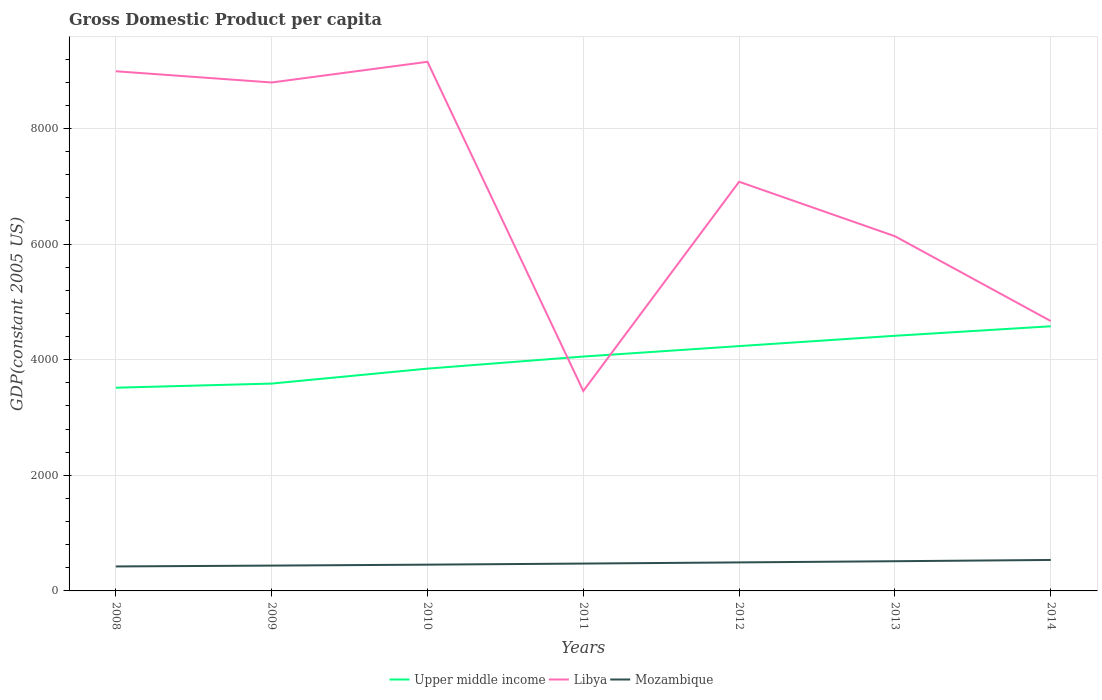How many different coloured lines are there?
Ensure brevity in your answer.  3. Does the line corresponding to Upper middle income intersect with the line corresponding to Mozambique?
Your answer should be compact. No. Across all years, what is the maximum GDP per capita in Mozambique?
Make the answer very short. 423.64. What is the total GDP per capita in Upper middle income in the graph?
Make the answer very short. -209.02. What is the difference between the highest and the second highest GDP per capita in Libya?
Provide a succinct answer. 5694.55. What is the difference between the highest and the lowest GDP per capita in Mozambique?
Keep it short and to the point. 3. How many years are there in the graph?
Make the answer very short. 7. What is the difference between two consecutive major ticks on the Y-axis?
Make the answer very short. 2000. Does the graph contain grids?
Provide a short and direct response. Yes. Where does the legend appear in the graph?
Keep it short and to the point. Bottom center. How are the legend labels stacked?
Provide a short and direct response. Horizontal. What is the title of the graph?
Keep it short and to the point. Gross Domestic Product per capita. Does "Gabon" appear as one of the legend labels in the graph?
Ensure brevity in your answer.  No. What is the label or title of the X-axis?
Provide a short and direct response. Years. What is the label or title of the Y-axis?
Offer a terse response. GDP(constant 2005 US). What is the GDP(constant 2005 US) of Upper middle income in 2008?
Ensure brevity in your answer.  3515.53. What is the GDP(constant 2005 US) of Libya in 2008?
Offer a very short reply. 8989.59. What is the GDP(constant 2005 US) in Mozambique in 2008?
Ensure brevity in your answer.  423.64. What is the GDP(constant 2005 US) in Upper middle income in 2009?
Your answer should be compact. 3586.78. What is the GDP(constant 2005 US) of Libya in 2009?
Give a very brief answer. 8795.52. What is the GDP(constant 2005 US) in Mozambique in 2009?
Your answer should be compact. 438.11. What is the GDP(constant 2005 US) in Upper middle income in 2010?
Ensure brevity in your answer.  3845.58. What is the GDP(constant 2005 US) in Libya in 2010?
Ensure brevity in your answer.  9153.11. What is the GDP(constant 2005 US) of Mozambique in 2010?
Make the answer very short. 454.46. What is the GDP(constant 2005 US) of Upper middle income in 2011?
Keep it short and to the point. 4054.59. What is the GDP(constant 2005 US) in Libya in 2011?
Give a very brief answer. 3458.56. What is the GDP(constant 2005 US) in Mozambique in 2011?
Your response must be concise. 473.27. What is the GDP(constant 2005 US) of Upper middle income in 2012?
Your response must be concise. 4235.11. What is the GDP(constant 2005 US) of Libya in 2012?
Provide a short and direct response. 7078.21. What is the GDP(constant 2005 US) of Mozambique in 2012?
Your answer should be very brief. 493.23. What is the GDP(constant 2005 US) of Upper middle income in 2013?
Offer a very short reply. 4413.71. What is the GDP(constant 2005 US) in Libya in 2013?
Provide a succinct answer. 6135.95. What is the GDP(constant 2005 US) of Mozambique in 2013?
Make the answer very short. 513.79. What is the GDP(constant 2005 US) of Upper middle income in 2014?
Offer a terse response. 4578.15. What is the GDP(constant 2005 US) in Libya in 2014?
Offer a terse response. 4668.54. What is the GDP(constant 2005 US) in Mozambique in 2014?
Provide a short and direct response. 535.73. Across all years, what is the maximum GDP(constant 2005 US) of Upper middle income?
Offer a very short reply. 4578.15. Across all years, what is the maximum GDP(constant 2005 US) in Libya?
Your response must be concise. 9153.11. Across all years, what is the maximum GDP(constant 2005 US) of Mozambique?
Ensure brevity in your answer.  535.73. Across all years, what is the minimum GDP(constant 2005 US) in Upper middle income?
Offer a terse response. 3515.53. Across all years, what is the minimum GDP(constant 2005 US) in Libya?
Keep it short and to the point. 3458.56. Across all years, what is the minimum GDP(constant 2005 US) in Mozambique?
Your answer should be compact. 423.64. What is the total GDP(constant 2005 US) in Upper middle income in the graph?
Make the answer very short. 2.82e+04. What is the total GDP(constant 2005 US) in Libya in the graph?
Offer a very short reply. 4.83e+04. What is the total GDP(constant 2005 US) in Mozambique in the graph?
Provide a short and direct response. 3332.23. What is the difference between the GDP(constant 2005 US) in Upper middle income in 2008 and that in 2009?
Offer a terse response. -71.25. What is the difference between the GDP(constant 2005 US) of Libya in 2008 and that in 2009?
Keep it short and to the point. 194.08. What is the difference between the GDP(constant 2005 US) of Mozambique in 2008 and that in 2009?
Ensure brevity in your answer.  -14.47. What is the difference between the GDP(constant 2005 US) in Upper middle income in 2008 and that in 2010?
Keep it short and to the point. -330.05. What is the difference between the GDP(constant 2005 US) of Libya in 2008 and that in 2010?
Make the answer very short. -163.52. What is the difference between the GDP(constant 2005 US) of Mozambique in 2008 and that in 2010?
Provide a succinct answer. -30.82. What is the difference between the GDP(constant 2005 US) in Upper middle income in 2008 and that in 2011?
Ensure brevity in your answer.  -539.06. What is the difference between the GDP(constant 2005 US) of Libya in 2008 and that in 2011?
Provide a succinct answer. 5531.03. What is the difference between the GDP(constant 2005 US) in Mozambique in 2008 and that in 2011?
Provide a short and direct response. -49.63. What is the difference between the GDP(constant 2005 US) in Upper middle income in 2008 and that in 2012?
Keep it short and to the point. -719.59. What is the difference between the GDP(constant 2005 US) in Libya in 2008 and that in 2012?
Make the answer very short. 1911.38. What is the difference between the GDP(constant 2005 US) of Mozambique in 2008 and that in 2012?
Your response must be concise. -69.58. What is the difference between the GDP(constant 2005 US) in Upper middle income in 2008 and that in 2013?
Keep it short and to the point. -898.18. What is the difference between the GDP(constant 2005 US) in Libya in 2008 and that in 2013?
Your response must be concise. 2853.64. What is the difference between the GDP(constant 2005 US) in Mozambique in 2008 and that in 2013?
Offer a terse response. -90.15. What is the difference between the GDP(constant 2005 US) in Upper middle income in 2008 and that in 2014?
Your answer should be compact. -1062.62. What is the difference between the GDP(constant 2005 US) in Libya in 2008 and that in 2014?
Make the answer very short. 4321.05. What is the difference between the GDP(constant 2005 US) of Mozambique in 2008 and that in 2014?
Provide a short and direct response. -112.09. What is the difference between the GDP(constant 2005 US) in Upper middle income in 2009 and that in 2010?
Ensure brevity in your answer.  -258.79. What is the difference between the GDP(constant 2005 US) of Libya in 2009 and that in 2010?
Offer a very short reply. -357.59. What is the difference between the GDP(constant 2005 US) of Mozambique in 2009 and that in 2010?
Make the answer very short. -16.35. What is the difference between the GDP(constant 2005 US) of Upper middle income in 2009 and that in 2011?
Offer a very short reply. -467.81. What is the difference between the GDP(constant 2005 US) of Libya in 2009 and that in 2011?
Offer a terse response. 5336.95. What is the difference between the GDP(constant 2005 US) of Mozambique in 2009 and that in 2011?
Make the answer very short. -35.17. What is the difference between the GDP(constant 2005 US) of Upper middle income in 2009 and that in 2012?
Your response must be concise. -648.33. What is the difference between the GDP(constant 2005 US) in Libya in 2009 and that in 2012?
Provide a short and direct response. 1717.31. What is the difference between the GDP(constant 2005 US) in Mozambique in 2009 and that in 2012?
Ensure brevity in your answer.  -55.12. What is the difference between the GDP(constant 2005 US) in Upper middle income in 2009 and that in 2013?
Make the answer very short. -826.92. What is the difference between the GDP(constant 2005 US) in Libya in 2009 and that in 2013?
Offer a terse response. 2659.57. What is the difference between the GDP(constant 2005 US) of Mozambique in 2009 and that in 2013?
Your response must be concise. -75.68. What is the difference between the GDP(constant 2005 US) in Upper middle income in 2009 and that in 2014?
Ensure brevity in your answer.  -991.37. What is the difference between the GDP(constant 2005 US) of Libya in 2009 and that in 2014?
Keep it short and to the point. 4126.98. What is the difference between the GDP(constant 2005 US) of Mozambique in 2009 and that in 2014?
Your response must be concise. -97.62. What is the difference between the GDP(constant 2005 US) of Upper middle income in 2010 and that in 2011?
Offer a very short reply. -209.02. What is the difference between the GDP(constant 2005 US) of Libya in 2010 and that in 2011?
Offer a terse response. 5694.55. What is the difference between the GDP(constant 2005 US) of Mozambique in 2010 and that in 2011?
Your response must be concise. -18.81. What is the difference between the GDP(constant 2005 US) of Upper middle income in 2010 and that in 2012?
Your answer should be compact. -389.54. What is the difference between the GDP(constant 2005 US) of Libya in 2010 and that in 2012?
Offer a very short reply. 2074.9. What is the difference between the GDP(constant 2005 US) in Mozambique in 2010 and that in 2012?
Offer a terse response. -38.76. What is the difference between the GDP(constant 2005 US) of Upper middle income in 2010 and that in 2013?
Provide a short and direct response. -568.13. What is the difference between the GDP(constant 2005 US) in Libya in 2010 and that in 2013?
Your answer should be compact. 3017.16. What is the difference between the GDP(constant 2005 US) in Mozambique in 2010 and that in 2013?
Offer a terse response. -59.33. What is the difference between the GDP(constant 2005 US) of Upper middle income in 2010 and that in 2014?
Keep it short and to the point. -732.57. What is the difference between the GDP(constant 2005 US) in Libya in 2010 and that in 2014?
Offer a terse response. 4484.57. What is the difference between the GDP(constant 2005 US) in Mozambique in 2010 and that in 2014?
Offer a very short reply. -81.26. What is the difference between the GDP(constant 2005 US) of Upper middle income in 2011 and that in 2012?
Give a very brief answer. -180.52. What is the difference between the GDP(constant 2005 US) of Libya in 2011 and that in 2012?
Your answer should be compact. -3619.65. What is the difference between the GDP(constant 2005 US) of Mozambique in 2011 and that in 2012?
Your response must be concise. -19.95. What is the difference between the GDP(constant 2005 US) of Upper middle income in 2011 and that in 2013?
Provide a short and direct response. -359.11. What is the difference between the GDP(constant 2005 US) of Libya in 2011 and that in 2013?
Offer a terse response. -2677.39. What is the difference between the GDP(constant 2005 US) in Mozambique in 2011 and that in 2013?
Your answer should be very brief. -40.52. What is the difference between the GDP(constant 2005 US) of Upper middle income in 2011 and that in 2014?
Offer a very short reply. -523.56. What is the difference between the GDP(constant 2005 US) in Libya in 2011 and that in 2014?
Your response must be concise. -1209.98. What is the difference between the GDP(constant 2005 US) in Mozambique in 2011 and that in 2014?
Provide a short and direct response. -62.45. What is the difference between the GDP(constant 2005 US) in Upper middle income in 2012 and that in 2013?
Your answer should be very brief. -178.59. What is the difference between the GDP(constant 2005 US) of Libya in 2012 and that in 2013?
Keep it short and to the point. 942.26. What is the difference between the GDP(constant 2005 US) of Mozambique in 2012 and that in 2013?
Make the answer very short. -20.56. What is the difference between the GDP(constant 2005 US) of Upper middle income in 2012 and that in 2014?
Your answer should be very brief. -343.03. What is the difference between the GDP(constant 2005 US) of Libya in 2012 and that in 2014?
Your answer should be very brief. 2409.67. What is the difference between the GDP(constant 2005 US) of Mozambique in 2012 and that in 2014?
Ensure brevity in your answer.  -42.5. What is the difference between the GDP(constant 2005 US) of Upper middle income in 2013 and that in 2014?
Offer a terse response. -164.44. What is the difference between the GDP(constant 2005 US) in Libya in 2013 and that in 2014?
Your response must be concise. 1467.41. What is the difference between the GDP(constant 2005 US) in Mozambique in 2013 and that in 2014?
Provide a succinct answer. -21.94. What is the difference between the GDP(constant 2005 US) in Upper middle income in 2008 and the GDP(constant 2005 US) in Libya in 2009?
Provide a short and direct response. -5279.99. What is the difference between the GDP(constant 2005 US) of Upper middle income in 2008 and the GDP(constant 2005 US) of Mozambique in 2009?
Provide a short and direct response. 3077.42. What is the difference between the GDP(constant 2005 US) in Libya in 2008 and the GDP(constant 2005 US) in Mozambique in 2009?
Give a very brief answer. 8551.48. What is the difference between the GDP(constant 2005 US) of Upper middle income in 2008 and the GDP(constant 2005 US) of Libya in 2010?
Make the answer very short. -5637.58. What is the difference between the GDP(constant 2005 US) of Upper middle income in 2008 and the GDP(constant 2005 US) of Mozambique in 2010?
Make the answer very short. 3061.07. What is the difference between the GDP(constant 2005 US) of Libya in 2008 and the GDP(constant 2005 US) of Mozambique in 2010?
Provide a short and direct response. 8535.13. What is the difference between the GDP(constant 2005 US) in Upper middle income in 2008 and the GDP(constant 2005 US) in Libya in 2011?
Keep it short and to the point. 56.97. What is the difference between the GDP(constant 2005 US) in Upper middle income in 2008 and the GDP(constant 2005 US) in Mozambique in 2011?
Your response must be concise. 3042.25. What is the difference between the GDP(constant 2005 US) of Libya in 2008 and the GDP(constant 2005 US) of Mozambique in 2011?
Ensure brevity in your answer.  8516.32. What is the difference between the GDP(constant 2005 US) in Upper middle income in 2008 and the GDP(constant 2005 US) in Libya in 2012?
Make the answer very short. -3562.68. What is the difference between the GDP(constant 2005 US) in Upper middle income in 2008 and the GDP(constant 2005 US) in Mozambique in 2012?
Keep it short and to the point. 3022.3. What is the difference between the GDP(constant 2005 US) in Libya in 2008 and the GDP(constant 2005 US) in Mozambique in 2012?
Ensure brevity in your answer.  8496.37. What is the difference between the GDP(constant 2005 US) in Upper middle income in 2008 and the GDP(constant 2005 US) in Libya in 2013?
Give a very brief answer. -2620.42. What is the difference between the GDP(constant 2005 US) of Upper middle income in 2008 and the GDP(constant 2005 US) of Mozambique in 2013?
Your answer should be compact. 3001.74. What is the difference between the GDP(constant 2005 US) in Libya in 2008 and the GDP(constant 2005 US) in Mozambique in 2013?
Ensure brevity in your answer.  8475.8. What is the difference between the GDP(constant 2005 US) of Upper middle income in 2008 and the GDP(constant 2005 US) of Libya in 2014?
Ensure brevity in your answer.  -1153.01. What is the difference between the GDP(constant 2005 US) of Upper middle income in 2008 and the GDP(constant 2005 US) of Mozambique in 2014?
Keep it short and to the point. 2979.8. What is the difference between the GDP(constant 2005 US) in Libya in 2008 and the GDP(constant 2005 US) in Mozambique in 2014?
Offer a terse response. 8453.86. What is the difference between the GDP(constant 2005 US) in Upper middle income in 2009 and the GDP(constant 2005 US) in Libya in 2010?
Your response must be concise. -5566.32. What is the difference between the GDP(constant 2005 US) in Upper middle income in 2009 and the GDP(constant 2005 US) in Mozambique in 2010?
Your answer should be compact. 3132.32. What is the difference between the GDP(constant 2005 US) of Libya in 2009 and the GDP(constant 2005 US) of Mozambique in 2010?
Give a very brief answer. 8341.05. What is the difference between the GDP(constant 2005 US) of Upper middle income in 2009 and the GDP(constant 2005 US) of Libya in 2011?
Offer a very short reply. 128.22. What is the difference between the GDP(constant 2005 US) in Upper middle income in 2009 and the GDP(constant 2005 US) in Mozambique in 2011?
Make the answer very short. 3113.51. What is the difference between the GDP(constant 2005 US) of Libya in 2009 and the GDP(constant 2005 US) of Mozambique in 2011?
Make the answer very short. 8322.24. What is the difference between the GDP(constant 2005 US) in Upper middle income in 2009 and the GDP(constant 2005 US) in Libya in 2012?
Give a very brief answer. -3491.43. What is the difference between the GDP(constant 2005 US) in Upper middle income in 2009 and the GDP(constant 2005 US) in Mozambique in 2012?
Ensure brevity in your answer.  3093.56. What is the difference between the GDP(constant 2005 US) in Libya in 2009 and the GDP(constant 2005 US) in Mozambique in 2012?
Offer a very short reply. 8302.29. What is the difference between the GDP(constant 2005 US) in Upper middle income in 2009 and the GDP(constant 2005 US) in Libya in 2013?
Your answer should be compact. -2549.17. What is the difference between the GDP(constant 2005 US) in Upper middle income in 2009 and the GDP(constant 2005 US) in Mozambique in 2013?
Your response must be concise. 3072.99. What is the difference between the GDP(constant 2005 US) of Libya in 2009 and the GDP(constant 2005 US) of Mozambique in 2013?
Provide a succinct answer. 8281.73. What is the difference between the GDP(constant 2005 US) in Upper middle income in 2009 and the GDP(constant 2005 US) in Libya in 2014?
Your response must be concise. -1081.76. What is the difference between the GDP(constant 2005 US) of Upper middle income in 2009 and the GDP(constant 2005 US) of Mozambique in 2014?
Ensure brevity in your answer.  3051.06. What is the difference between the GDP(constant 2005 US) of Libya in 2009 and the GDP(constant 2005 US) of Mozambique in 2014?
Keep it short and to the point. 8259.79. What is the difference between the GDP(constant 2005 US) in Upper middle income in 2010 and the GDP(constant 2005 US) in Libya in 2011?
Make the answer very short. 387.01. What is the difference between the GDP(constant 2005 US) of Upper middle income in 2010 and the GDP(constant 2005 US) of Mozambique in 2011?
Provide a succinct answer. 3372.3. What is the difference between the GDP(constant 2005 US) of Libya in 2010 and the GDP(constant 2005 US) of Mozambique in 2011?
Provide a succinct answer. 8679.83. What is the difference between the GDP(constant 2005 US) in Upper middle income in 2010 and the GDP(constant 2005 US) in Libya in 2012?
Offer a terse response. -3232.63. What is the difference between the GDP(constant 2005 US) in Upper middle income in 2010 and the GDP(constant 2005 US) in Mozambique in 2012?
Offer a very short reply. 3352.35. What is the difference between the GDP(constant 2005 US) in Libya in 2010 and the GDP(constant 2005 US) in Mozambique in 2012?
Keep it short and to the point. 8659.88. What is the difference between the GDP(constant 2005 US) of Upper middle income in 2010 and the GDP(constant 2005 US) of Libya in 2013?
Your answer should be compact. -2290.37. What is the difference between the GDP(constant 2005 US) of Upper middle income in 2010 and the GDP(constant 2005 US) of Mozambique in 2013?
Your answer should be compact. 3331.79. What is the difference between the GDP(constant 2005 US) in Libya in 2010 and the GDP(constant 2005 US) in Mozambique in 2013?
Your answer should be compact. 8639.32. What is the difference between the GDP(constant 2005 US) in Upper middle income in 2010 and the GDP(constant 2005 US) in Libya in 2014?
Offer a terse response. -822.96. What is the difference between the GDP(constant 2005 US) in Upper middle income in 2010 and the GDP(constant 2005 US) in Mozambique in 2014?
Provide a short and direct response. 3309.85. What is the difference between the GDP(constant 2005 US) in Libya in 2010 and the GDP(constant 2005 US) in Mozambique in 2014?
Make the answer very short. 8617.38. What is the difference between the GDP(constant 2005 US) in Upper middle income in 2011 and the GDP(constant 2005 US) in Libya in 2012?
Your answer should be very brief. -3023.62. What is the difference between the GDP(constant 2005 US) in Upper middle income in 2011 and the GDP(constant 2005 US) in Mozambique in 2012?
Your answer should be compact. 3561.37. What is the difference between the GDP(constant 2005 US) in Libya in 2011 and the GDP(constant 2005 US) in Mozambique in 2012?
Give a very brief answer. 2965.34. What is the difference between the GDP(constant 2005 US) of Upper middle income in 2011 and the GDP(constant 2005 US) of Libya in 2013?
Provide a short and direct response. -2081.36. What is the difference between the GDP(constant 2005 US) in Upper middle income in 2011 and the GDP(constant 2005 US) in Mozambique in 2013?
Your answer should be compact. 3540.8. What is the difference between the GDP(constant 2005 US) in Libya in 2011 and the GDP(constant 2005 US) in Mozambique in 2013?
Ensure brevity in your answer.  2944.77. What is the difference between the GDP(constant 2005 US) of Upper middle income in 2011 and the GDP(constant 2005 US) of Libya in 2014?
Ensure brevity in your answer.  -613.95. What is the difference between the GDP(constant 2005 US) of Upper middle income in 2011 and the GDP(constant 2005 US) of Mozambique in 2014?
Ensure brevity in your answer.  3518.87. What is the difference between the GDP(constant 2005 US) in Libya in 2011 and the GDP(constant 2005 US) in Mozambique in 2014?
Your response must be concise. 2922.83. What is the difference between the GDP(constant 2005 US) of Upper middle income in 2012 and the GDP(constant 2005 US) of Libya in 2013?
Your answer should be very brief. -1900.83. What is the difference between the GDP(constant 2005 US) of Upper middle income in 2012 and the GDP(constant 2005 US) of Mozambique in 2013?
Ensure brevity in your answer.  3721.32. What is the difference between the GDP(constant 2005 US) of Libya in 2012 and the GDP(constant 2005 US) of Mozambique in 2013?
Your response must be concise. 6564.42. What is the difference between the GDP(constant 2005 US) of Upper middle income in 2012 and the GDP(constant 2005 US) of Libya in 2014?
Keep it short and to the point. -433.42. What is the difference between the GDP(constant 2005 US) in Upper middle income in 2012 and the GDP(constant 2005 US) in Mozambique in 2014?
Ensure brevity in your answer.  3699.39. What is the difference between the GDP(constant 2005 US) in Libya in 2012 and the GDP(constant 2005 US) in Mozambique in 2014?
Offer a terse response. 6542.48. What is the difference between the GDP(constant 2005 US) of Upper middle income in 2013 and the GDP(constant 2005 US) of Libya in 2014?
Offer a very short reply. -254.83. What is the difference between the GDP(constant 2005 US) in Upper middle income in 2013 and the GDP(constant 2005 US) in Mozambique in 2014?
Offer a terse response. 3877.98. What is the difference between the GDP(constant 2005 US) in Libya in 2013 and the GDP(constant 2005 US) in Mozambique in 2014?
Your answer should be very brief. 5600.22. What is the average GDP(constant 2005 US) of Upper middle income per year?
Provide a short and direct response. 4032.78. What is the average GDP(constant 2005 US) in Libya per year?
Offer a terse response. 6897.07. What is the average GDP(constant 2005 US) in Mozambique per year?
Your answer should be compact. 476.03. In the year 2008, what is the difference between the GDP(constant 2005 US) of Upper middle income and GDP(constant 2005 US) of Libya?
Provide a short and direct response. -5474.06. In the year 2008, what is the difference between the GDP(constant 2005 US) of Upper middle income and GDP(constant 2005 US) of Mozambique?
Provide a succinct answer. 3091.89. In the year 2008, what is the difference between the GDP(constant 2005 US) in Libya and GDP(constant 2005 US) in Mozambique?
Ensure brevity in your answer.  8565.95. In the year 2009, what is the difference between the GDP(constant 2005 US) in Upper middle income and GDP(constant 2005 US) in Libya?
Offer a terse response. -5208.73. In the year 2009, what is the difference between the GDP(constant 2005 US) of Upper middle income and GDP(constant 2005 US) of Mozambique?
Keep it short and to the point. 3148.67. In the year 2009, what is the difference between the GDP(constant 2005 US) in Libya and GDP(constant 2005 US) in Mozambique?
Ensure brevity in your answer.  8357.41. In the year 2010, what is the difference between the GDP(constant 2005 US) of Upper middle income and GDP(constant 2005 US) of Libya?
Offer a terse response. -5307.53. In the year 2010, what is the difference between the GDP(constant 2005 US) in Upper middle income and GDP(constant 2005 US) in Mozambique?
Your response must be concise. 3391.11. In the year 2010, what is the difference between the GDP(constant 2005 US) in Libya and GDP(constant 2005 US) in Mozambique?
Give a very brief answer. 8698.65. In the year 2011, what is the difference between the GDP(constant 2005 US) in Upper middle income and GDP(constant 2005 US) in Libya?
Offer a very short reply. 596.03. In the year 2011, what is the difference between the GDP(constant 2005 US) of Upper middle income and GDP(constant 2005 US) of Mozambique?
Your answer should be very brief. 3581.32. In the year 2011, what is the difference between the GDP(constant 2005 US) of Libya and GDP(constant 2005 US) of Mozambique?
Your answer should be very brief. 2985.29. In the year 2012, what is the difference between the GDP(constant 2005 US) in Upper middle income and GDP(constant 2005 US) in Libya?
Provide a succinct answer. -2843.09. In the year 2012, what is the difference between the GDP(constant 2005 US) of Upper middle income and GDP(constant 2005 US) of Mozambique?
Offer a very short reply. 3741.89. In the year 2012, what is the difference between the GDP(constant 2005 US) in Libya and GDP(constant 2005 US) in Mozambique?
Make the answer very short. 6584.98. In the year 2013, what is the difference between the GDP(constant 2005 US) of Upper middle income and GDP(constant 2005 US) of Libya?
Provide a succinct answer. -1722.24. In the year 2013, what is the difference between the GDP(constant 2005 US) of Upper middle income and GDP(constant 2005 US) of Mozambique?
Your response must be concise. 3899.92. In the year 2013, what is the difference between the GDP(constant 2005 US) in Libya and GDP(constant 2005 US) in Mozambique?
Provide a short and direct response. 5622.16. In the year 2014, what is the difference between the GDP(constant 2005 US) of Upper middle income and GDP(constant 2005 US) of Libya?
Provide a succinct answer. -90.39. In the year 2014, what is the difference between the GDP(constant 2005 US) of Upper middle income and GDP(constant 2005 US) of Mozambique?
Ensure brevity in your answer.  4042.42. In the year 2014, what is the difference between the GDP(constant 2005 US) of Libya and GDP(constant 2005 US) of Mozambique?
Provide a succinct answer. 4132.81. What is the ratio of the GDP(constant 2005 US) in Upper middle income in 2008 to that in 2009?
Give a very brief answer. 0.98. What is the ratio of the GDP(constant 2005 US) of Libya in 2008 to that in 2009?
Your response must be concise. 1.02. What is the ratio of the GDP(constant 2005 US) in Mozambique in 2008 to that in 2009?
Your response must be concise. 0.97. What is the ratio of the GDP(constant 2005 US) of Upper middle income in 2008 to that in 2010?
Provide a succinct answer. 0.91. What is the ratio of the GDP(constant 2005 US) of Libya in 2008 to that in 2010?
Offer a very short reply. 0.98. What is the ratio of the GDP(constant 2005 US) of Mozambique in 2008 to that in 2010?
Make the answer very short. 0.93. What is the ratio of the GDP(constant 2005 US) of Upper middle income in 2008 to that in 2011?
Ensure brevity in your answer.  0.87. What is the ratio of the GDP(constant 2005 US) of Libya in 2008 to that in 2011?
Ensure brevity in your answer.  2.6. What is the ratio of the GDP(constant 2005 US) in Mozambique in 2008 to that in 2011?
Your answer should be compact. 0.9. What is the ratio of the GDP(constant 2005 US) in Upper middle income in 2008 to that in 2012?
Your answer should be compact. 0.83. What is the ratio of the GDP(constant 2005 US) of Libya in 2008 to that in 2012?
Make the answer very short. 1.27. What is the ratio of the GDP(constant 2005 US) in Mozambique in 2008 to that in 2012?
Offer a terse response. 0.86. What is the ratio of the GDP(constant 2005 US) of Upper middle income in 2008 to that in 2013?
Give a very brief answer. 0.8. What is the ratio of the GDP(constant 2005 US) in Libya in 2008 to that in 2013?
Make the answer very short. 1.47. What is the ratio of the GDP(constant 2005 US) of Mozambique in 2008 to that in 2013?
Provide a short and direct response. 0.82. What is the ratio of the GDP(constant 2005 US) in Upper middle income in 2008 to that in 2014?
Provide a short and direct response. 0.77. What is the ratio of the GDP(constant 2005 US) of Libya in 2008 to that in 2014?
Keep it short and to the point. 1.93. What is the ratio of the GDP(constant 2005 US) of Mozambique in 2008 to that in 2014?
Your answer should be very brief. 0.79. What is the ratio of the GDP(constant 2005 US) in Upper middle income in 2009 to that in 2010?
Make the answer very short. 0.93. What is the ratio of the GDP(constant 2005 US) of Libya in 2009 to that in 2010?
Make the answer very short. 0.96. What is the ratio of the GDP(constant 2005 US) of Mozambique in 2009 to that in 2010?
Offer a very short reply. 0.96. What is the ratio of the GDP(constant 2005 US) in Upper middle income in 2009 to that in 2011?
Give a very brief answer. 0.88. What is the ratio of the GDP(constant 2005 US) of Libya in 2009 to that in 2011?
Make the answer very short. 2.54. What is the ratio of the GDP(constant 2005 US) in Mozambique in 2009 to that in 2011?
Make the answer very short. 0.93. What is the ratio of the GDP(constant 2005 US) of Upper middle income in 2009 to that in 2012?
Your answer should be very brief. 0.85. What is the ratio of the GDP(constant 2005 US) in Libya in 2009 to that in 2012?
Provide a succinct answer. 1.24. What is the ratio of the GDP(constant 2005 US) of Mozambique in 2009 to that in 2012?
Offer a terse response. 0.89. What is the ratio of the GDP(constant 2005 US) of Upper middle income in 2009 to that in 2013?
Ensure brevity in your answer.  0.81. What is the ratio of the GDP(constant 2005 US) of Libya in 2009 to that in 2013?
Make the answer very short. 1.43. What is the ratio of the GDP(constant 2005 US) of Mozambique in 2009 to that in 2013?
Your answer should be very brief. 0.85. What is the ratio of the GDP(constant 2005 US) of Upper middle income in 2009 to that in 2014?
Keep it short and to the point. 0.78. What is the ratio of the GDP(constant 2005 US) in Libya in 2009 to that in 2014?
Your answer should be compact. 1.88. What is the ratio of the GDP(constant 2005 US) of Mozambique in 2009 to that in 2014?
Ensure brevity in your answer.  0.82. What is the ratio of the GDP(constant 2005 US) in Upper middle income in 2010 to that in 2011?
Provide a short and direct response. 0.95. What is the ratio of the GDP(constant 2005 US) of Libya in 2010 to that in 2011?
Ensure brevity in your answer.  2.65. What is the ratio of the GDP(constant 2005 US) of Mozambique in 2010 to that in 2011?
Ensure brevity in your answer.  0.96. What is the ratio of the GDP(constant 2005 US) in Upper middle income in 2010 to that in 2012?
Your answer should be very brief. 0.91. What is the ratio of the GDP(constant 2005 US) in Libya in 2010 to that in 2012?
Offer a terse response. 1.29. What is the ratio of the GDP(constant 2005 US) of Mozambique in 2010 to that in 2012?
Your answer should be compact. 0.92. What is the ratio of the GDP(constant 2005 US) of Upper middle income in 2010 to that in 2013?
Your answer should be very brief. 0.87. What is the ratio of the GDP(constant 2005 US) in Libya in 2010 to that in 2013?
Your answer should be compact. 1.49. What is the ratio of the GDP(constant 2005 US) in Mozambique in 2010 to that in 2013?
Give a very brief answer. 0.88. What is the ratio of the GDP(constant 2005 US) in Upper middle income in 2010 to that in 2014?
Offer a terse response. 0.84. What is the ratio of the GDP(constant 2005 US) in Libya in 2010 to that in 2014?
Provide a succinct answer. 1.96. What is the ratio of the GDP(constant 2005 US) in Mozambique in 2010 to that in 2014?
Your response must be concise. 0.85. What is the ratio of the GDP(constant 2005 US) in Upper middle income in 2011 to that in 2012?
Keep it short and to the point. 0.96. What is the ratio of the GDP(constant 2005 US) of Libya in 2011 to that in 2012?
Keep it short and to the point. 0.49. What is the ratio of the GDP(constant 2005 US) in Mozambique in 2011 to that in 2012?
Offer a terse response. 0.96. What is the ratio of the GDP(constant 2005 US) in Upper middle income in 2011 to that in 2013?
Your response must be concise. 0.92. What is the ratio of the GDP(constant 2005 US) in Libya in 2011 to that in 2013?
Ensure brevity in your answer.  0.56. What is the ratio of the GDP(constant 2005 US) in Mozambique in 2011 to that in 2013?
Your response must be concise. 0.92. What is the ratio of the GDP(constant 2005 US) in Upper middle income in 2011 to that in 2014?
Give a very brief answer. 0.89. What is the ratio of the GDP(constant 2005 US) of Libya in 2011 to that in 2014?
Keep it short and to the point. 0.74. What is the ratio of the GDP(constant 2005 US) of Mozambique in 2011 to that in 2014?
Give a very brief answer. 0.88. What is the ratio of the GDP(constant 2005 US) in Upper middle income in 2012 to that in 2013?
Ensure brevity in your answer.  0.96. What is the ratio of the GDP(constant 2005 US) of Libya in 2012 to that in 2013?
Ensure brevity in your answer.  1.15. What is the ratio of the GDP(constant 2005 US) of Upper middle income in 2012 to that in 2014?
Keep it short and to the point. 0.93. What is the ratio of the GDP(constant 2005 US) in Libya in 2012 to that in 2014?
Offer a terse response. 1.52. What is the ratio of the GDP(constant 2005 US) in Mozambique in 2012 to that in 2014?
Provide a short and direct response. 0.92. What is the ratio of the GDP(constant 2005 US) in Upper middle income in 2013 to that in 2014?
Make the answer very short. 0.96. What is the ratio of the GDP(constant 2005 US) in Libya in 2013 to that in 2014?
Your answer should be very brief. 1.31. What is the ratio of the GDP(constant 2005 US) in Mozambique in 2013 to that in 2014?
Provide a succinct answer. 0.96. What is the difference between the highest and the second highest GDP(constant 2005 US) in Upper middle income?
Ensure brevity in your answer.  164.44. What is the difference between the highest and the second highest GDP(constant 2005 US) in Libya?
Give a very brief answer. 163.52. What is the difference between the highest and the second highest GDP(constant 2005 US) of Mozambique?
Make the answer very short. 21.94. What is the difference between the highest and the lowest GDP(constant 2005 US) of Upper middle income?
Provide a succinct answer. 1062.62. What is the difference between the highest and the lowest GDP(constant 2005 US) in Libya?
Provide a succinct answer. 5694.55. What is the difference between the highest and the lowest GDP(constant 2005 US) in Mozambique?
Make the answer very short. 112.09. 